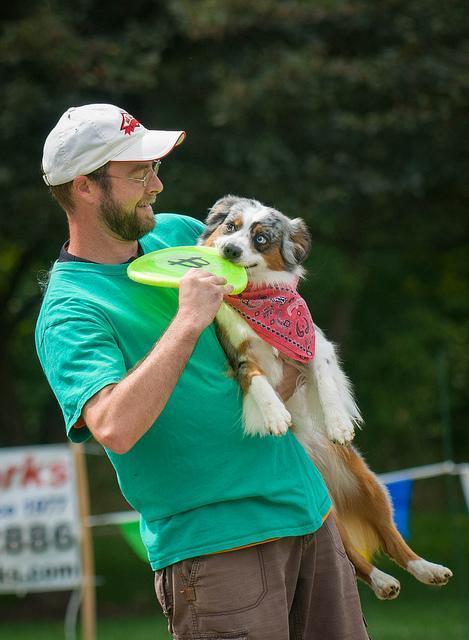How many people are in the photo?
Give a very brief answer. 1. How many cars do you see in the background?
Give a very brief answer. 0. 